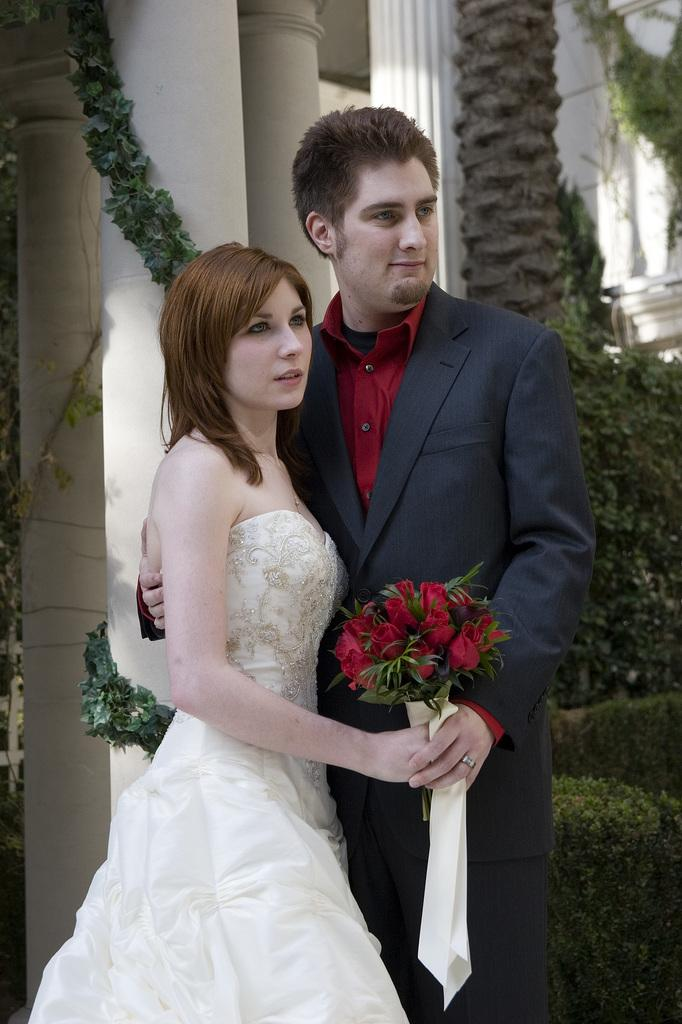What is the man doing with the woman in the image? The man is holding the woman in the image. What can be seen besides the man and woman in the image? There is a flower bouquet, cloth, pillars, plants, and a wall visible in the image. Can you describe the background of the image? The background of the image includes pillars, plants, and a wall. How many giants are present in the image? There are no giants present in the image. What type of answer can be found in the image? The image does not contain any answers, as it is a visual representation and not a source of textual information. 